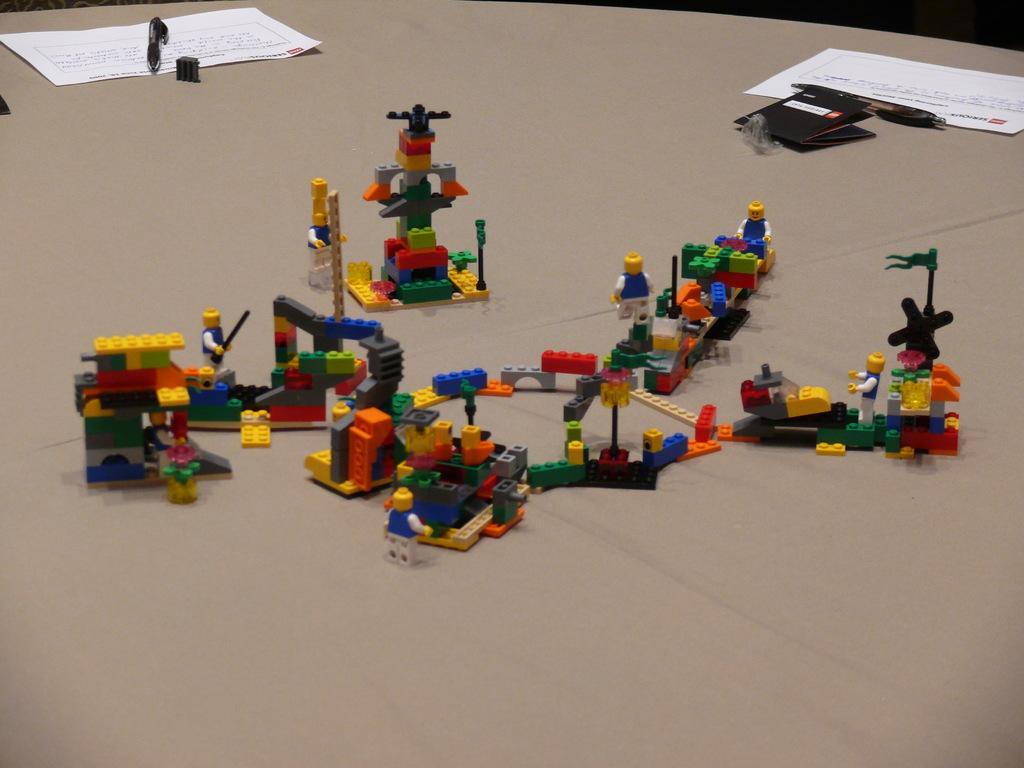What items can be seen in the image related to writing or drawing? There are papers and pens in the image. What type of toys are present in the image? There are Lego toys in the image. Where is the mailbox located in the image? There is no mailbox present in the image. What type of animal is playing with the Lego toys in the image? There is no animal, such as a monkey, present in the image. 